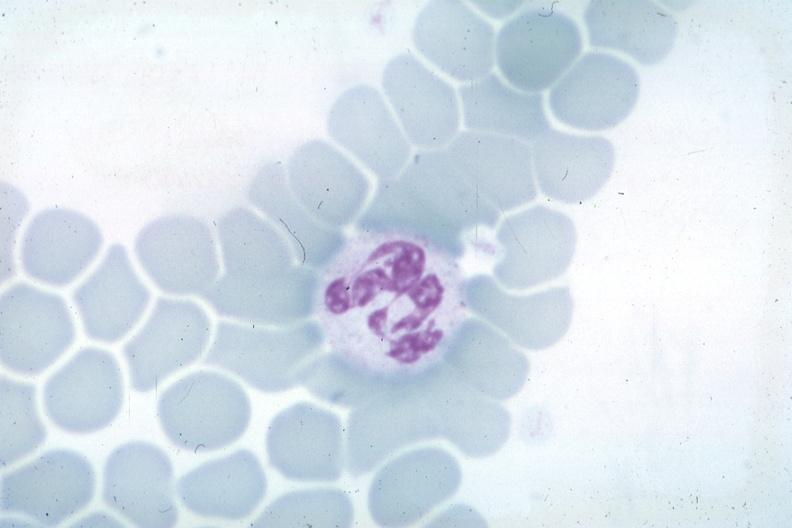s peritoneal fluid present?
Answer the question using a single word or phrase. No 